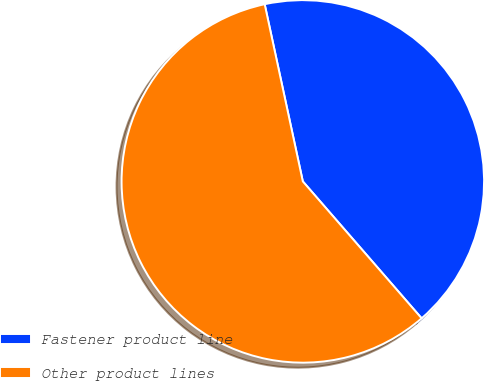Convert chart. <chart><loc_0><loc_0><loc_500><loc_500><pie_chart><fcel>Fastener product line<fcel>Other product lines<nl><fcel>42.0%<fcel>58.0%<nl></chart> 